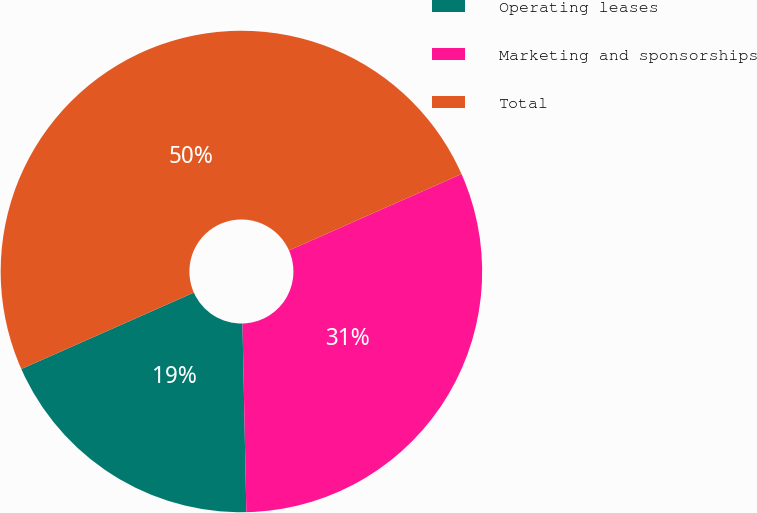Convert chart. <chart><loc_0><loc_0><loc_500><loc_500><pie_chart><fcel>Operating leases<fcel>Marketing and sponsorships<fcel>Total<nl><fcel>18.69%<fcel>31.31%<fcel>50.0%<nl></chart> 